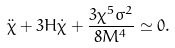Convert formula to latex. <formula><loc_0><loc_0><loc_500><loc_500>\ddot { \chi } + 3 H \dot { \chi } + \frac { 3 \chi ^ { 5 } \sigma ^ { 2 } } { 8 M ^ { 4 } } \simeq 0 .</formula> 